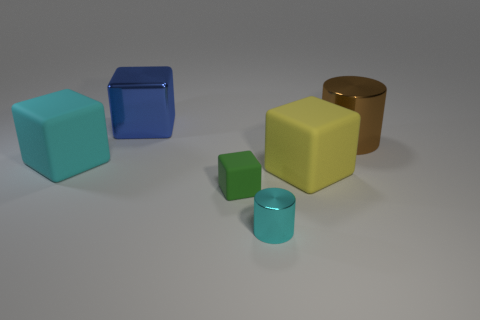Are there an equal number of small metal cylinders left of the tiny cyan cylinder and small cyan metal cylinders?
Your response must be concise. No. There is a cylinder behind the rubber block left of the tiny object on the left side of the tiny metal cylinder; what is its material?
Make the answer very short. Metal. What is the material of the block that is the same color as the small metallic cylinder?
Ensure brevity in your answer.  Rubber. What number of things are large matte blocks that are right of the tiny rubber block or metallic things?
Offer a very short reply. 4. What number of objects are brown objects or large objects that are left of the big brown cylinder?
Provide a succinct answer. 4. What number of blocks are in front of the cylinder behind the cyan thing that is behind the tiny metallic thing?
Offer a very short reply. 3. There is a yellow thing that is the same size as the metal block; what is it made of?
Your response must be concise. Rubber. Are there any blue metallic cubes of the same size as the cyan matte object?
Ensure brevity in your answer.  Yes. What color is the tiny metal object?
Ensure brevity in your answer.  Cyan. There is a cylinder behind the object on the left side of the blue metal block; what is its color?
Offer a very short reply. Brown. 